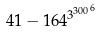Convert formula to latex. <formula><loc_0><loc_0><loc_500><loc_500>4 1 - 1 6 4 ^ { { 3 ^ { 3 0 0 } } ^ { 6 } }</formula> 